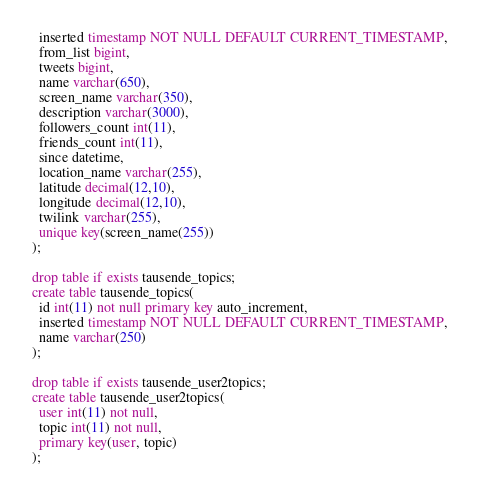Convert code to text. <code><loc_0><loc_0><loc_500><loc_500><_SQL_>  inserted timestamp NOT NULL DEFAULT CURRENT_TIMESTAMP,
  from_list bigint,
  tweets bigint,
  name varchar(650),
  screen_name varchar(350),
  description varchar(3000),
  followers_count int(11),
  friends_count int(11),
  since datetime,
  location_name varchar(255),
  latitude decimal(12,10),
  longitude decimal(12,10),
  twilink varchar(255),
  unique key(screen_name(255))
);

drop table if exists tausende_topics;
create table tausende_topics(
  id int(11) not null primary key auto_increment,
  inserted timestamp NOT NULL DEFAULT CURRENT_TIMESTAMP,
  name varchar(250)
);

drop table if exists tausende_user2topics;
create table tausende_user2topics(
  user int(11) not null,
  topic int(11) not null,
  primary key(user, topic)
);

</code> 